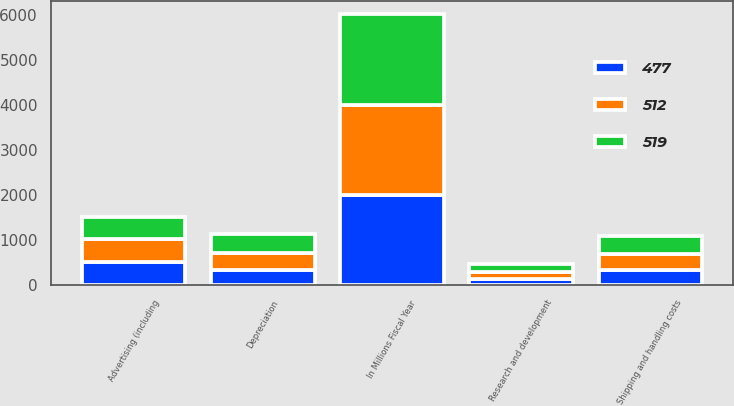Convert chart. <chart><loc_0><loc_0><loc_500><loc_500><stacked_bar_chart><ecel><fcel>In Millions Fiscal Year<fcel>Depreciation<fcel>Shipping and handling costs<fcel>Research and development<fcel>Advertising (including<nl><fcel>519<fcel>2005<fcel>415<fcel>388<fcel>168<fcel>477<nl><fcel>512<fcel>2004<fcel>376<fcel>352<fcel>158<fcel>512<nl><fcel>477<fcel>2003<fcel>347<fcel>345<fcel>149<fcel>519<nl></chart> 